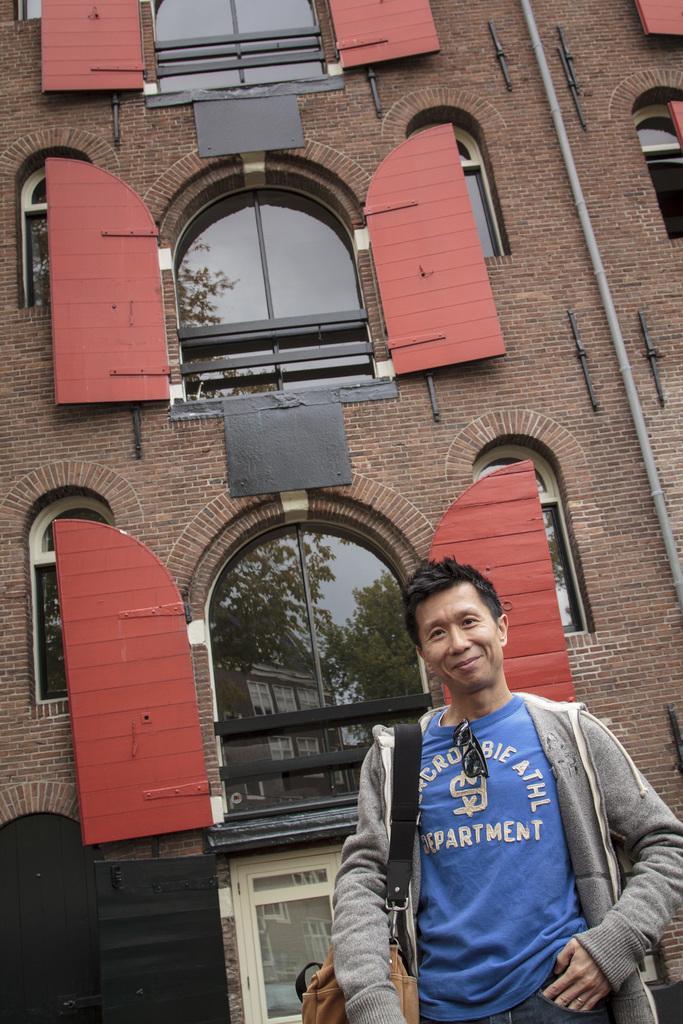Describe this image in one or two sentences. In this picture there is a person standing and wearing a grey color jacket and there is a building behind him which has few windows and doors attached to the walls of the building. 